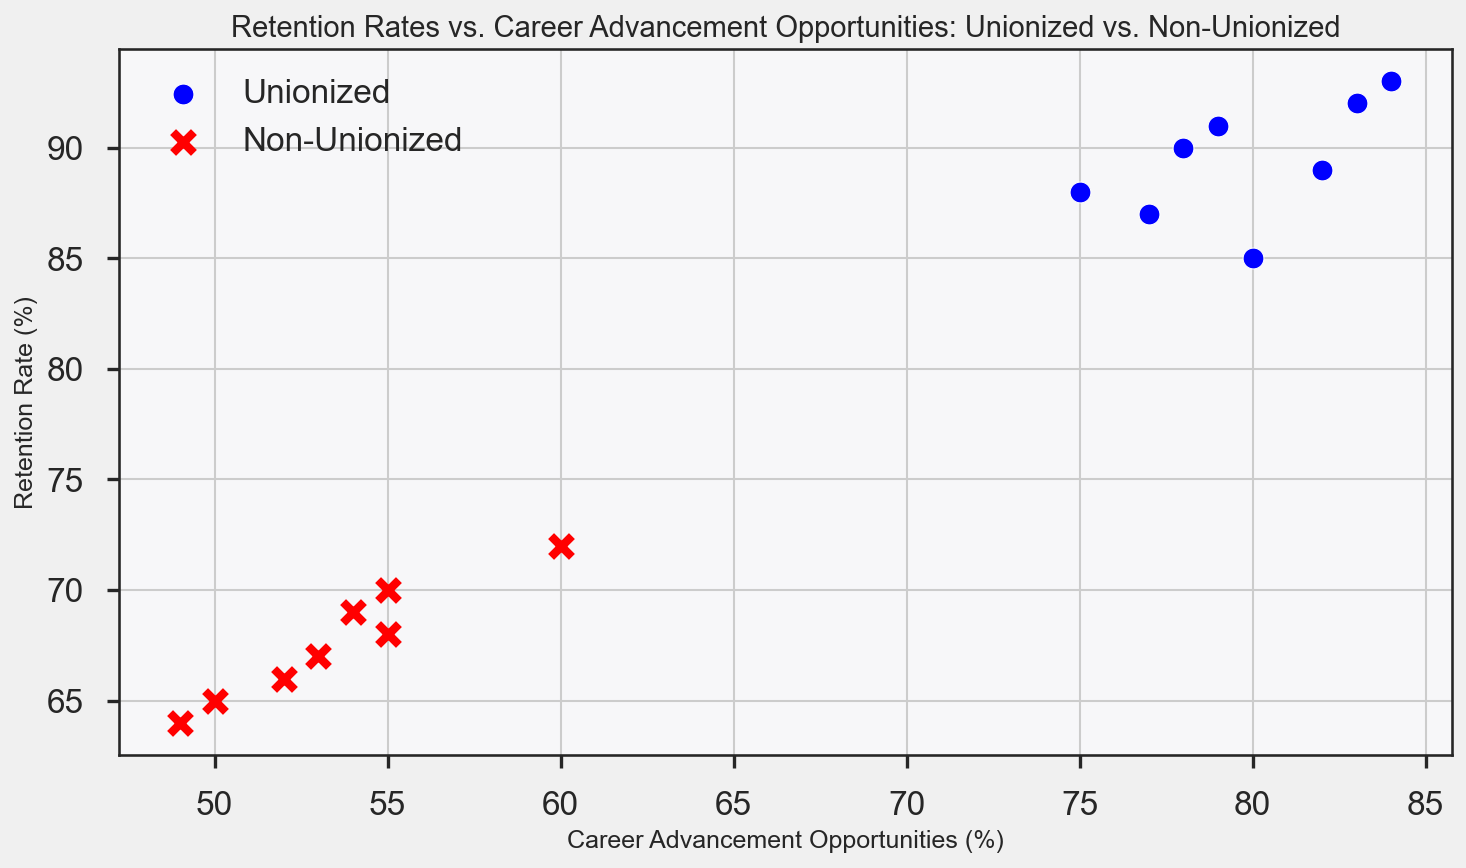What group has higher retention rates overall? Observing the scatter plot, the blue dots representing the unionized workers generally have higher retention rates compared to the red 'x' marks representing the non-unionized workers.
Answer: Unionized workers How do the career advancement opportunities compare between unionized and non-unionized workers? From the plot, the unionized group (blue dots) tends to have higher career advancement opportunities than the non-unionized group (red 'x' marks).
Answer: Unionized workers Which group has more variability in retention rates? The range of retention rates among the non-unionized workers (red 'x' marks) is broader, indicating more variability compared to the more clustered blue dots (unionized).
Answer: Non-unionized workers What's the average retention rate for unionized workers? Sum of retention rates for unionized workers: (88+85+90+92+87+89+91+93) = 715. Number of unionized data points = 8. Average retention rate = 715/8 = 89.375
Answer: 89.375 What's the maximum career advancement opportunity observed for non-unionized workers? The highest value among the non-unionized group's career advancement opportunities is identified from the plot. The maximum value is 60.
Answer: 60 Compare the trend of retention rates relative to career advancement opportunities between the two groups. Both groups show a positive trend between career advancement opportunities and retention rates. However, unionized workers have generally higher values in both aspects compared to non-unionized workers.
Answer: Unionized workers have higher values How can we visually distinguish between unionized and non-unionized workers on the plot? Unionized workers are represented by blue round dots, while non-unionized workers are shown as red 'x' marks.
Answer: Color and shape (blue dots for unionized, red 'x' for non-unionized) By how much does the highest retention rate differ between unionized and non-unionized workers? The highest retention rate for unionized workers is 93 and for non-unionized it is 72. The difference is 93 - 72 = 21.
Answer: 21 What's the correlation between retention rates and career advancement opportunities for unionized workers? The scatter plot for the unionized group shows a positive trend, indicating that higher career advancement opportunities tend to correlate with higher retention rates among unionized workers.
Answer: Positive correlation Which group shows a more consistent relationship between retention rates and career advancement opportunities? The unionized workers have a more consistent and tightly clustered relationship between retention and advancement opportunities compared to non-unionized workers.
Answer: Unionized workers 